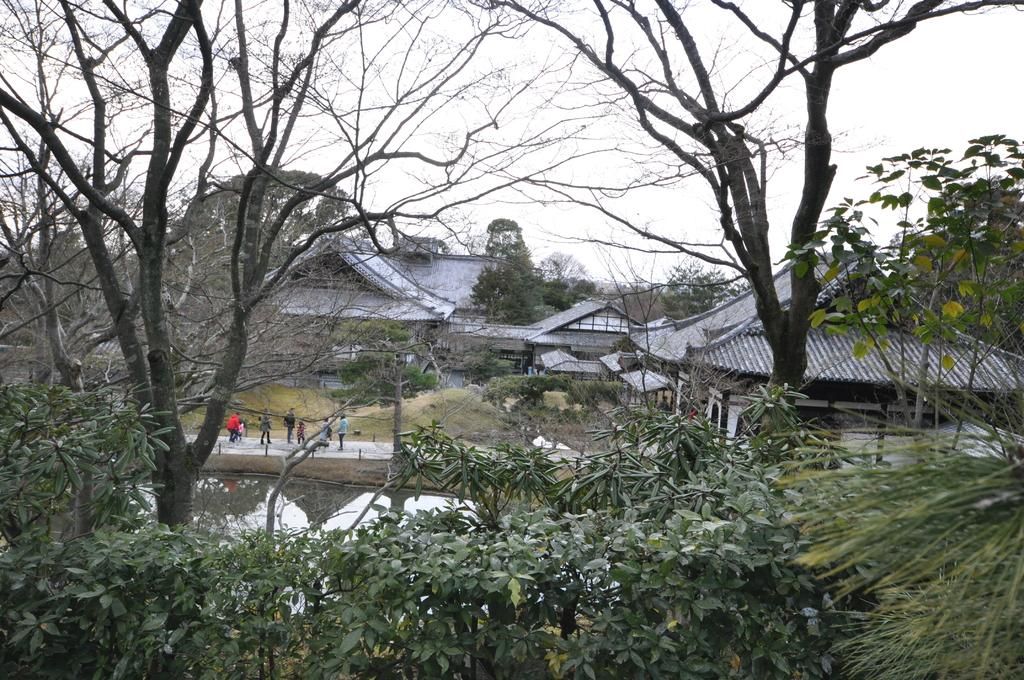What type of natural elements can be seen in the image? There are trees in the image. What type of man-made structures are present in the image? There are buildings in the image. What body of water is visible in the image? There is water visible in the image. Are there any people present in the image? Yes, there are people standing in the image. What type of coil can be seen in the image? There is no coil present in the image. What type of structure is the people standing on in the image? The provided facts do not mention any specific structure that the people are standing on, so we cannot determine the type of structure from the image. 